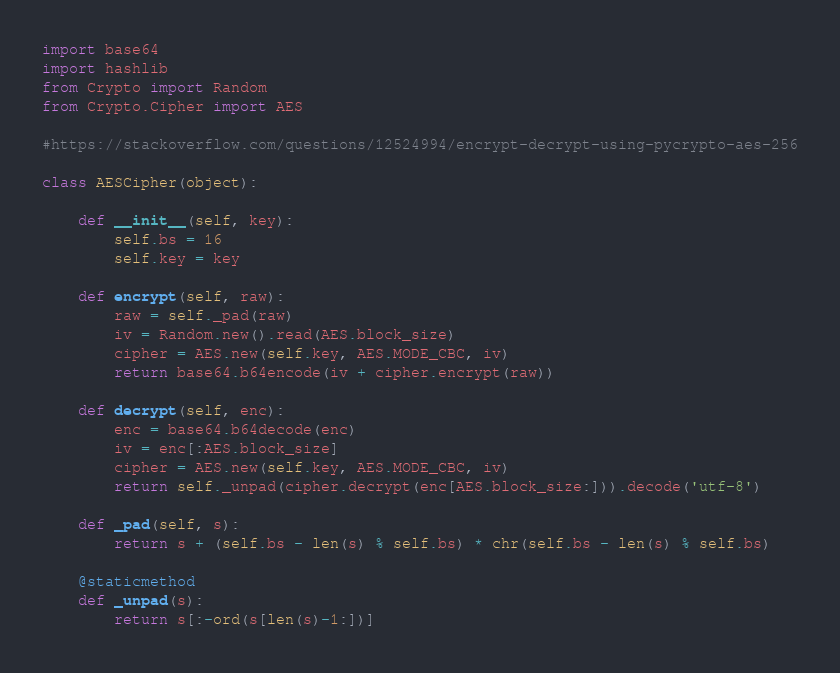Convert code to text. <code><loc_0><loc_0><loc_500><loc_500><_Python_>import base64
import hashlib
from Crypto import Random
from Crypto.Cipher import AES

#https://stackoverflow.com/questions/12524994/encrypt-decrypt-using-pycrypto-aes-256

class AESCipher(object):

    def __init__(self, key): 
        self.bs = 16
        self.key = key

    def encrypt(self, raw):
        raw = self._pad(raw)
        iv = Random.new().read(AES.block_size)
        cipher = AES.new(self.key, AES.MODE_CBC, iv)
        return base64.b64encode(iv + cipher.encrypt(raw))

    def decrypt(self, enc):
        enc = base64.b64decode(enc)
        iv = enc[:AES.block_size]
        cipher = AES.new(self.key, AES.MODE_CBC, iv)
        return self._unpad(cipher.decrypt(enc[AES.block_size:])).decode('utf-8')

    def _pad(self, s):
        return s + (self.bs - len(s) % self.bs) * chr(self.bs - len(s) % self.bs)

    @staticmethod
    def _unpad(s):
        return s[:-ord(s[len(s)-1:])]
</code> 